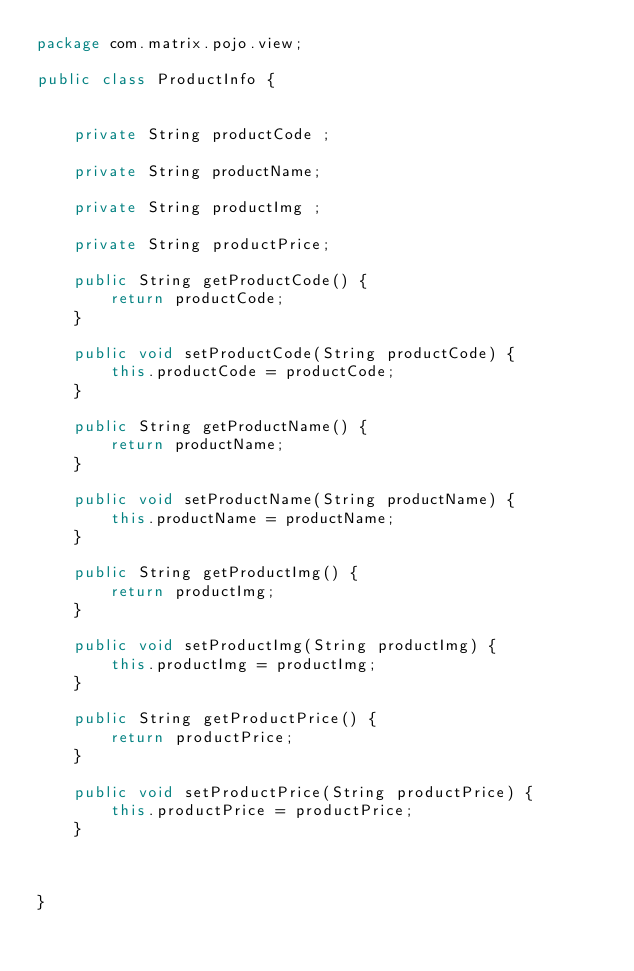<code> <loc_0><loc_0><loc_500><loc_500><_Java_>package com.matrix.pojo.view;

public class ProductInfo {

	
	private String productCode ;
	
	private String productName;
	
	private String productImg ;
	
	private String productPrice;

	public String getProductCode() {
		return productCode;
	}

	public void setProductCode(String productCode) {
		this.productCode = productCode;
	}

	public String getProductName() {
		return productName;
	}

	public void setProductName(String productName) {
		this.productName = productName;
	}

	public String getProductImg() {
		return productImg;
	}

	public void setProductImg(String productImg) {
		this.productImg = productImg;
	}

	public String getProductPrice() {
		return productPrice;
	}

	public void setProductPrice(String productPrice) {
		this.productPrice = productPrice;
	}
	
	
	
}
</code> 